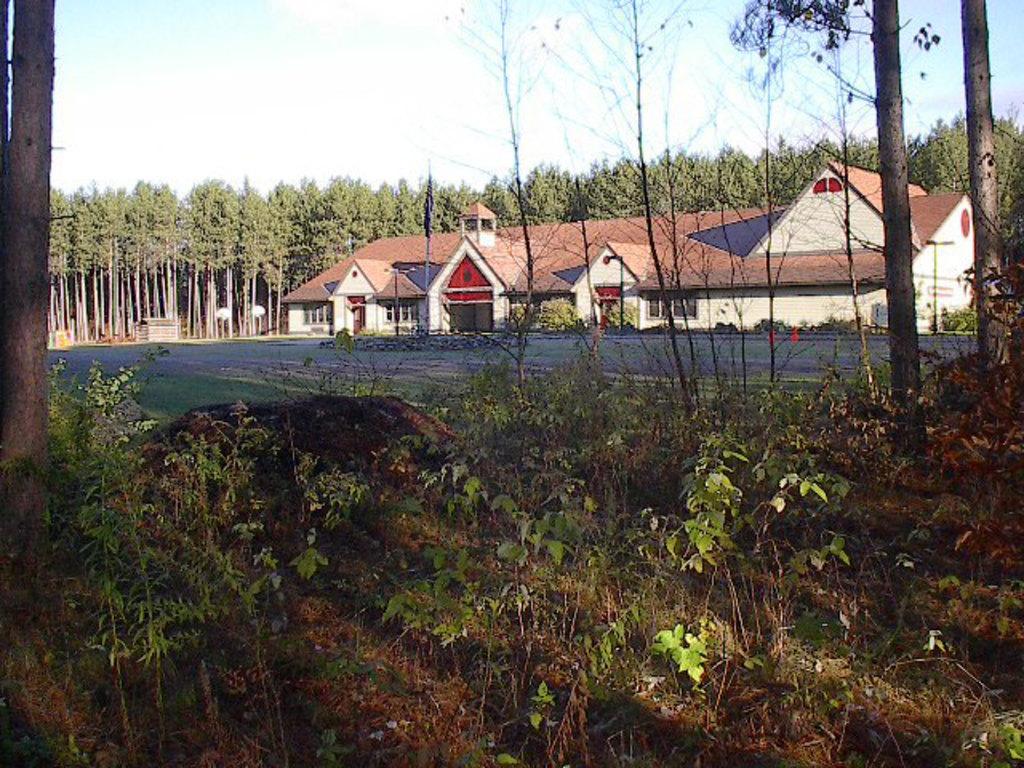In one or two sentences, can you explain what this image depicts? In this image I can see at the bottom there are plants, in the middle there are houses. At the back side there are trees, at the top it is the sky. 